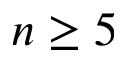Convert formula to latex. <formula><loc_0><loc_0><loc_500><loc_500>n \geq 5</formula> 